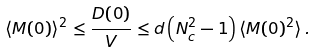<formula> <loc_0><loc_0><loc_500><loc_500>\langle M ( 0 ) \rangle ^ { 2 } \leq \frac { D ( 0 ) } { V } \leq d \left ( N ^ { 2 } _ { c } - 1 \right ) \langle M ( 0 ) ^ { 2 } \rangle \, .</formula> 